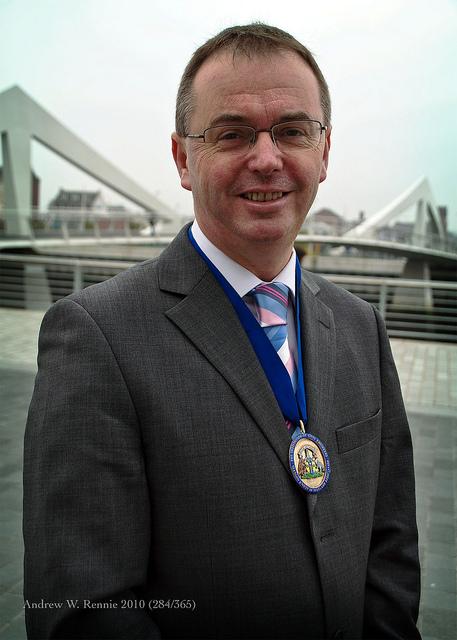What does this man have hanging from his neck?
Give a very brief answer. Medal. Is this man happy?
Concise answer only. Yes. What is this man's name?
Keep it brief. Andrew. 